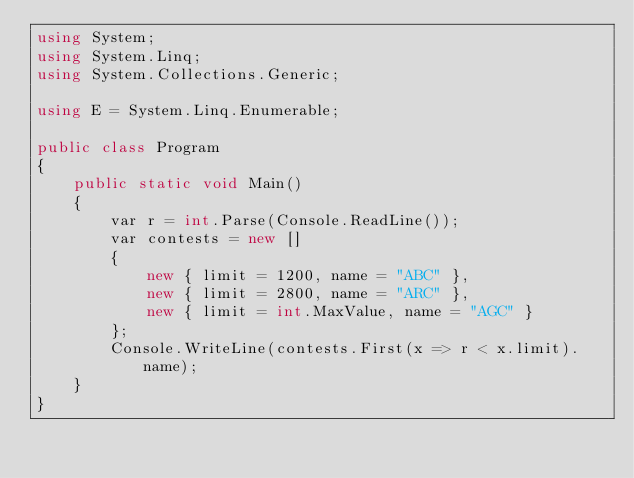Convert code to text. <code><loc_0><loc_0><loc_500><loc_500><_C#_>using System;
using System.Linq;
using System.Collections.Generic;

using E = System.Linq.Enumerable;

public class Program
{
    public static void Main()
    {
        var r = int.Parse(Console.ReadLine());
        var contests = new [] 
        { 
            new { limit = 1200, name = "ABC" },
            new { limit = 2800, name = "ARC" },
            new { limit = int.MaxValue, name = "AGC" }
        };
        Console.WriteLine(contests.First(x => r < x.limit).name);
    }
}</code> 